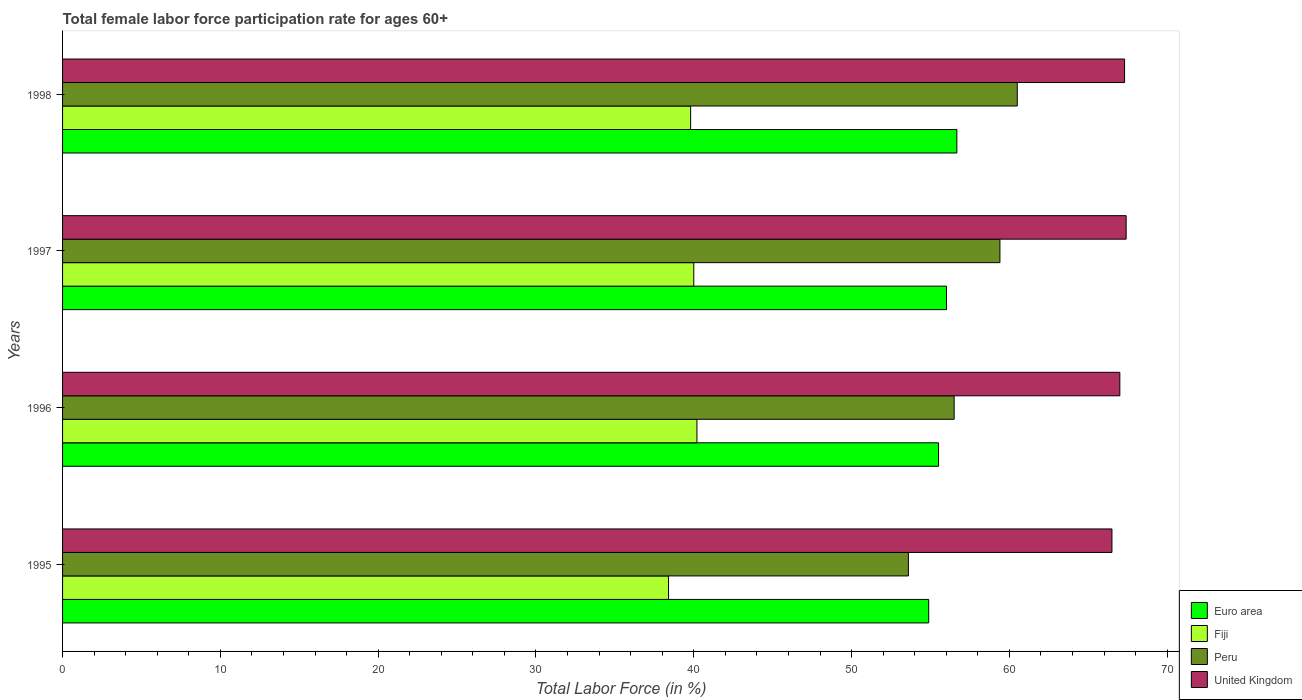How many different coloured bars are there?
Ensure brevity in your answer.  4. How many groups of bars are there?
Your answer should be compact. 4. How many bars are there on the 4th tick from the top?
Provide a short and direct response. 4. How many bars are there on the 3rd tick from the bottom?
Provide a short and direct response. 4. What is the label of the 1st group of bars from the top?
Give a very brief answer. 1998. In how many cases, is the number of bars for a given year not equal to the number of legend labels?
Ensure brevity in your answer.  0. What is the female labor force participation rate in Peru in 1996?
Give a very brief answer. 56.5. Across all years, what is the maximum female labor force participation rate in United Kingdom?
Give a very brief answer. 67.4. Across all years, what is the minimum female labor force participation rate in United Kingdom?
Give a very brief answer. 66.5. What is the total female labor force participation rate in Peru in the graph?
Give a very brief answer. 230. What is the difference between the female labor force participation rate in Fiji in 1997 and that in 1998?
Your answer should be compact. 0.2. What is the difference between the female labor force participation rate in Peru in 1996 and the female labor force participation rate in United Kingdom in 1995?
Make the answer very short. -10. What is the average female labor force participation rate in Fiji per year?
Provide a succinct answer. 39.6. In the year 1995, what is the difference between the female labor force participation rate in Fiji and female labor force participation rate in Peru?
Offer a terse response. -15.2. In how many years, is the female labor force participation rate in Peru greater than 6 %?
Ensure brevity in your answer.  4. What is the ratio of the female labor force participation rate in Euro area in 1997 to that in 1998?
Your answer should be very brief. 0.99. Is the difference between the female labor force participation rate in Fiji in 1996 and 1998 greater than the difference between the female labor force participation rate in Peru in 1996 and 1998?
Ensure brevity in your answer.  Yes. What is the difference between the highest and the second highest female labor force participation rate in Fiji?
Keep it short and to the point. 0.2. What is the difference between the highest and the lowest female labor force participation rate in United Kingdom?
Provide a short and direct response. 0.9. Is the sum of the female labor force participation rate in Fiji in 1996 and 1997 greater than the maximum female labor force participation rate in United Kingdom across all years?
Provide a succinct answer. Yes. Is it the case that in every year, the sum of the female labor force participation rate in Fiji and female labor force participation rate in Euro area is greater than the sum of female labor force participation rate in United Kingdom and female labor force participation rate in Peru?
Your answer should be very brief. No. Is it the case that in every year, the sum of the female labor force participation rate in Peru and female labor force participation rate in Euro area is greater than the female labor force participation rate in United Kingdom?
Your response must be concise. Yes. How many bars are there?
Your response must be concise. 16. Are all the bars in the graph horizontal?
Make the answer very short. Yes. What is the difference between two consecutive major ticks on the X-axis?
Ensure brevity in your answer.  10. Are the values on the major ticks of X-axis written in scientific E-notation?
Your answer should be compact. No. Does the graph contain any zero values?
Your response must be concise. No. Does the graph contain grids?
Ensure brevity in your answer.  No. How are the legend labels stacked?
Provide a succinct answer. Vertical. What is the title of the graph?
Offer a very short reply. Total female labor force participation rate for ages 60+. Does "Qatar" appear as one of the legend labels in the graph?
Your answer should be compact. No. What is the label or title of the X-axis?
Your answer should be very brief. Total Labor Force (in %). What is the label or title of the Y-axis?
Your answer should be compact. Years. What is the Total Labor Force (in %) of Euro area in 1995?
Offer a very short reply. 54.89. What is the Total Labor Force (in %) in Fiji in 1995?
Your response must be concise. 38.4. What is the Total Labor Force (in %) in Peru in 1995?
Provide a short and direct response. 53.6. What is the Total Labor Force (in %) in United Kingdom in 1995?
Offer a very short reply. 66.5. What is the Total Labor Force (in %) of Euro area in 1996?
Your response must be concise. 55.51. What is the Total Labor Force (in %) of Fiji in 1996?
Your answer should be compact. 40.2. What is the Total Labor Force (in %) of Peru in 1996?
Provide a short and direct response. 56.5. What is the Total Labor Force (in %) of Euro area in 1997?
Your answer should be compact. 56.02. What is the Total Labor Force (in %) of Fiji in 1997?
Provide a short and direct response. 40. What is the Total Labor Force (in %) in Peru in 1997?
Offer a terse response. 59.4. What is the Total Labor Force (in %) in United Kingdom in 1997?
Your response must be concise. 67.4. What is the Total Labor Force (in %) in Euro area in 1998?
Your answer should be very brief. 56.67. What is the Total Labor Force (in %) in Fiji in 1998?
Provide a short and direct response. 39.8. What is the Total Labor Force (in %) of Peru in 1998?
Keep it short and to the point. 60.5. What is the Total Labor Force (in %) in United Kingdom in 1998?
Offer a very short reply. 67.3. Across all years, what is the maximum Total Labor Force (in %) of Euro area?
Your answer should be compact. 56.67. Across all years, what is the maximum Total Labor Force (in %) of Fiji?
Ensure brevity in your answer.  40.2. Across all years, what is the maximum Total Labor Force (in %) of Peru?
Offer a terse response. 60.5. Across all years, what is the maximum Total Labor Force (in %) in United Kingdom?
Offer a terse response. 67.4. Across all years, what is the minimum Total Labor Force (in %) of Euro area?
Offer a terse response. 54.89. Across all years, what is the minimum Total Labor Force (in %) in Fiji?
Your answer should be compact. 38.4. Across all years, what is the minimum Total Labor Force (in %) in Peru?
Offer a very short reply. 53.6. Across all years, what is the minimum Total Labor Force (in %) of United Kingdom?
Offer a very short reply. 66.5. What is the total Total Labor Force (in %) of Euro area in the graph?
Provide a short and direct response. 223.08. What is the total Total Labor Force (in %) of Fiji in the graph?
Keep it short and to the point. 158.4. What is the total Total Labor Force (in %) in Peru in the graph?
Give a very brief answer. 230. What is the total Total Labor Force (in %) of United Kingdom in the graph?
Ensure brevity in your answer.  268.2. What is the difference between the Total Labor Force (in %) of Euro area in 1995 and that in 1996?
Keep it short and to the point. -0.62. What is the difference between the Total Labor Force (in %) of United Kingdom in 1995 and that in 1996?
Offer a very short reply. -0.5. What is the difference between the Total Labor Force (in %) of Euro area in 1995 and that in 1997?
Give a very brief answer. -1.13. What is the difference between the Total Labor Force (in %) in United Kingdom in 1995 and that in 1997?
Your answer should be compact. -0.9. What is the difference between the Total Labor Force (in %) of Euro area in 1995 and that in 1998?
Make the answer very short. -1.78. What is the difference between the Total Labor Force (in %) of United Kingdom in 1995 and that in 1998?
Make the answer very short. -0.8. What is the difference between the Total Labor Force (in %) in Euro area in 1996 and that in 1997?
Keep it short and to the point. -0.51. What is the difference between the Total Labor Force (in %) of Fiji in 1996 and that in 1997?
Provide a short and direct response. 0.2. What is the difference between the Total Labor Force (in %) in Peru in 1996 and that in 1997?
Offer a very short reply. -2.9. What is the difference between the Total Labor Force (in %) of United Kingdom in 1996 and that in 1997?
Offer a terse response. -0.4. What is the difference between the Total Labor Force (in %) in Euro area in 1996 and that in 1998?
Make the answer very short. -1.16. What is the difference between the Total Labor Force (in %) in Peru in 1996 and that in 1998?
Offer a terse response. -4. What is the difference between the Total Labor Force (in %) in United Kingdom in 1996 and that in 1998?
Make the answer very short. -0.3. What is the difference between the Total Labor Force (in %) of Euro area in 1997 and that in 1998?
Make the answer very short. -0.65. What is the difference between the Total Labor Force (in %) of United Kingdom in 1997 and that in 1998?
Provide a succinct answer. 0.1. What is the difference between the Total Labor Force (in %) of Euro area in 1995 and the Total Labor Force (in %) of Fiji in 1996?
Your answer should be very brief. 14.69. What is the difference between the Total Labor Force (in %) of Euro area in 1995 and the Total Labor Force (in %) of Peru in 1996?
Ensure brevity in your answer.  -1.61. What is the difference between the Total Labor Force (in %) of Euro area in 1995 and the Total Labor Force (in %) of United Kingdom in 1996?
Your answer should be very brief. -12.11. What is the difference between the Total Labor Force (in %) of Fiji in 1995 and the Total Labor Force (in %) of Peru in 1996?
Offer a terse response. -18.1. What is the difference between the Total Labor Force (in %) in Fiji in 1995 and the Total Labor Force (in %) in United Kingdom in 1996?
Your answer should be very brief. -28.6. What is the difference between the Total Labor Force (in %) in Peru in 1995 and the Total Labor Force (in %) in United Kingdom in 1996?
Ensure brevity in your answer.  -13.4. What is the difference between the Total Labor Force (in %) in Euro area in 1995 and the Total Labor Force (in %) in Fiji in 1997?
Offer a very short reply. 14.89. What is the difference between the Total Labor Force (in %) in Euro area in 1995 and the Total Labor Force (in %) in Peru in 1997?
Offer a terse response. -4.51. What is the difference between the Total Labor Force (in %) in Euro area in 1995 and the Total Labor Force (in %) in United Kingdom in 1997?
Give a very brief answer. -12.51. What is the difference between the Total Labor Force (in %) in Fiji in 1995 and the Total Labor Force (in %) in Peru in 1997?
Your answer should be compact. -21. What is the difference between the Total Labor Force (in %) of Fiji in 1995 and the Total Labor Force (in %) of United Kingdom in 1997?
Offer a very short reply. -29. What is the difference between the Total Labor Force (in %) of Euro area in 1995 and the Total Labor Force (in %) of Fiji in 1998?
Your answer should be very brief. 15.09. What is the difference between the Total Labor Force (in %) in Euro area in 1995 and the Total Labor Force (in %) in Peru in 1998?
Provide a succinct answer. -5.61. What is the difference between the Total Labor Force (in %) of Euro area in 1995 and the Total Labor Force (in %) of United Kingdom in 1998?
Make the answer very short. -12.41. What is the difference between the Total Labor Force (in %) of Fiji in 1995 and the Total Labor Force (in %) of Peru in 1998?
Make the answer very short. -22.1. What is the difference between the Total Labor Force (in %) in Fiji in 1995 and the Total Labor Force (in %) in United Kingdom in 1998?
Make the answer very short. -28.9. What is the difference between the Total Labor Force (in %) in Peru in 1995 and the Total Labor Force (in %) in United Kingdom in 1998?
Your answer should be very brief. -13.7. What is the difference between the Total Labor Force (in %) of Euro area in 1996 and the Total Labor Force (in %) of Fiji in 1997?
Your response must be concise. 15.51. What is the difference between the Total Labor Force (in %) in Euro area in 1996 and the Total Labor Force (in %) in Peru in 1997?
Your response must be concise. -3.89. What is the difference between the Total Labor Force (in %) of Euro area in 1996 and the Total Labor Force (in %) of United Kingdom in 1997?
Your answer should be very brief. -11.89. What is the difference between the Total Labor Force (in %) in Fiji in 1996 and the Total Labor Force (in %) in Peru in 1997?
Offer a terse response. -19.2. What is the difference between the Total Labor Force (in %) in Fiji in 1996 and the Total Labor Force (in %) in United Kingdom in 1997?
Give a very brief answer. -27.2. What is the difference between the Total Labor Force (in %) of Peru in 1996 and the Total Labor Force (in %) of United Kingdom in 1997?
Ensure brevity in your answer.  -10.9. What is the difference between the Total Labor Force (in %) of Euro area in 1996 and the Total Labor Force (in %) of Fiji in 1998?
Make the answer very short. 15.71. What is the difference between the Total Labor Force (in %) in Euro area in 1996 and the Total Labor Force (in %) in Peru in 1998?
Your answer should be very brief. -4.99. What is the difference between the Total Labor Force (in %) of Euro area in 1996 and the Total Labor Force (in %) of United Kingdom in 1998?
Provide a succinct answer. -11.79. What is the difference between the Total Labor Force (in %) of Fiji in 1996 and the Total Labor Force (in %) of Peru in 1998?
Your response must be concise. -20.3. What is the difference between the Total Labor Force (in %) of Fiji in 1996 and the Total Labor Force (in %) of United Kingdom in 1998?
Your answer should be very brief. -27.1. What is the difference between the Total Labor Force (in %) in Peru in 1996 and the Total Labor Force (in %) in United Kingdom in 1998?
Ensure brevity in your answer.  -10.8. What is the difference between the Total Labor Force (in %) of Euro area in 1997 and the Total Labor Force (in %) of Fiji in 1998?
Make the answer very short. 16.22. What is the difference between the Total Labor Force (in %) in Euro area in 1997 and the Total Labor Force (in %) in Peru in 1998?
Your answer should be compact. -4.48. What is the difference between the Total Labor Force (in %) in Euro area in 1997 and the Total Labor Force (in %) in United Kingdom in 1998?
Give a very brief answer. -11.28. What is the difference between the Total Labor Force (in %) in Fiji in 1997 and the Total Labor Force (in %) in Peru in 1998?
Keep it short and to the point. -20.5. What is the difference between the Total Labor Force (in %) of Fiji in 1997 and the Total Labor Force (in %) of United Kingdom in 1998?
Your answer should be compact. -27.3. What is the difference between the Total Labor Force (in %) of Peru in 1997 and the Total Labor Force (in %) of United Kingdom in 1998?
Provide a short and direct response. -7.9. What is the average Total Labor Force (in %) in Euro area per year?
Make the answer very short. 55.77. What is the average Total Labor Force (in %) of Fiji per year?
Your answer should be very brief. 39.6. What is the average Total Labor Force (in %) of Peru per year?
Keep it short and to the point. 57.5. What is the average Total Labor Force (in %) in United Kingdom per year?
Ensure brevity in your answer.  67.05. In the year 1995, what is the difference between the Total Labor Force (in %) of Euro area and Total Labor Force (in %) of Fiji?
Provide a short and direct response. 16.49. In the year 1995, what is the difference between the Total Labor Force (in %) in Euro area and Total Labor Force (in %) in Peru?
Your answer should be very brief. 1.29. In the year 1995, what is the difference between the Total Labor Force (in %) in Euro area and Total Labor Force (in %) in United Kingdom?
Offer a very short reply. -11.61. In the year 1995, what is the difference between the Total Labor Force (in %) in Fiji and Total Labor Force (in %) in Peru?
Ensure brevity in your answer.  -15.2. In the year 1995, what is the difference between the Total Labor Force (in %) in Fiji and Total Labor Force (in %) in United Kingdom?
Offer a very short reply. -28.1. In the year 1995, what is the difference between the Total Labor Force (in %) of Peru and Total Labor Force (in %) of United Kingdom?
Make the answer very short. -12.9. In the year 1996, what is the difference between the Total Labor Force (in %) in Euro area and Total Labor Force (in %) in Fiji?
Ensure brevity in your answer.  15.31. In the year 1996, what is the difference between the Total Labor Force (in %) in Euro area and Total Labor Force (in %) in Peru?
Offer a very short reply. -0.99. In the year 1996, what is the difference between the Total Labor Force (in %) in Euro area and Total Labor Force (in %) in United Kingdom?
Offer a terse response. -11.49. In the year 1996, what is the difference between the Total Labor Force (in %) in Fiji and Total Labor Force (in %) in Peru?
Your answer should be compact. -16.3. In the year 1996, what is the difference between the Total Labor Force (in %) in Fiji and Total Labor Force (in %) in United Kingdom?
Provide a short and direct response. -26.8. In the year 1996, what is the difference between the Total Labor Force (in %) in Peru and Total Labor Force (in %) in United Kingdom?
Your response must be concise. -10.5. In the year 1997, what is the difference between the Total Labor Force (in %) in Euro area and Total Labor Force (in %) in Fiji?
Provide a short and direct response. 16.02. In the year 1997, what is the difference between the Total Labor Force (in %) in Euro area and Total Labor Force (in %) in Peru?
Your answer should be compact. -3.38. In the year 1997, what is the difference between the Total Labor Force (in %) in Euro area and Total Labor Force (in %) in United Kingdom?
Provide a short and direct response. -11.38. In the year 1997, what is the difference between the Total Labor Force (in %) of Fiji and Total Labor Force (in %) of Peru?
Offer a terse response. -19.4. In the year 1997, what is the difference between the Total Labor Force (in %) in Fiji and Total Labor Force (in %) in United Kingdom?
Give a very brief answer. -27.4. In the year 1997, what is the difference between the Total Labor Force (in %) in Peru and Total Labor Force (in %) in United Kingdom?
Offer a terse response. -8. In the year 1998, what is the difference between the Total Labor Force (in %) in Euro area and Total Labor Force (in %) in Fiji?
Your response must be concise. 16.87. In the year 1998, what is the difference between the Total Labor Force (in %) of Euro area and Total Labor Force (in %) of Peru?
Keep it short and to the point. -3.83. In the year 1998, what is the difference between the Total Labor Force (in %) of Euro area and Total Labor Force (in %) of United Kingdom?
Provide a succinct answer. -10.63. In the year 1998, what is the difference between the Total Labor Force (in %) in Fiji and Total Labor Force (in %) in Peru?
Keep it short and to the point. -20.7. In the year 1998, what is the difference between the Total Labor Force (in %) in Fiji and Total Labor Force (in %) in United Kingdom?
Your response must be concise. -27.5. What is the ratio of the Total Labor Force (in %) of Euro area in 1995 to that in 1996?
Your response must be concise. 0.99. What is the ratio of the Total Labor Force (in %) of Fiji in 1995 to that in 1996?
Give a very brief answer. 0.96. What is the ratio of the Total Labor Force (in %) in Peru in 1995 to that in 1996?
Your response must be concise. 0.95. What is the ratio of the Total Labor Force (in %) of United Kingdom in 1995 to that in 1996?
Make the answer very short. 0.99. What is the ratio of the Total Labor Force (in %) in Euro area in 1995 to that in 1997?
Give a very brief answer. 0.98. What is the ratio of the Total Labor Force (in %) of Fiji in 1995 to that in 1997?
Your response must be concise. 0.96. What is the ratio of the Total Labor Force (in %) in Peru in 1995 to that in 1997?
Ensure brevity in your answer.  0.9. What is the ratio of the Total Labor Force (in %) in United Kingdom in 1995 to that in 1997?
Offer a very short reply. 0.99. What is the ratio of the Total Labor Force (in %) of Euro area in 1995 to that in 1998?
Provide a short and direct response. 0.97. What is the ratio of the Total Labor Force (in %) of Fiji in 1995 to that in 1998?
Provide a short and direct response. 0.96. What is the ratio of the Total Labor Force (in %) of Peru in 1995 to that in 1998?
Provide a short and direct response. 0.89. What is the ratio of the Total Labor Force (in %) in United Kingdom in 1995 to that in 1998?
Your answer should be compact. 0.99. What is the ratio of the Total Labor Force (in %) of Peru in 1996 to that in 1997?
Give a very brief answer. 0.95. What is the ratio of the Total Labor Force (in %) in United Kingdom in 1996 to that in 1997?
Your response must be concise. 0.99. What is the ratio of the Total Labor Force (in %) in Euro area in 1996 to that in 1998?
Keep it short and to the point. 0.98. What is the ratio of the Total Labor Force (in %) of Fiji in 1996 to that in 1998?
Offer a very short reply. 1.01. What is the ratio of the Total Labor Force (in %) in Peru in 1996 to that in 1998?
Make the answer very short. 0.93. What is the ratio of the Total Labor Force (in %) in United Kingdom in 1996 to that in 1998?
Keep it short and to the point. 1. What is the ratio of the Total Labor Force (in %) of Euro area in 1997 to that in 1998?
Give a very brief answer. 0.99. What is the ratio of the Total Labor Force (in %) of Fiji in 1997 to that in 1998?
Your answer should be very brief. 1. What is the ratio of the Total Labor Force (in %) of Peru in 1997 to that in 1998?
Make the answer very short. 0.98. What is the difference between the highest and the second highest Total Labor Force (in %) in Euro area?
Your response must be concise. 0.65. What is the difference between the highest and the lowest Total Labor Force (in %) in Euro area?
Ensure brevity in your answer.  1.78. What is the difference between the highest and the lowest Total Labor Force (in %) in Peru?
Offer a very short reply. 6.9. What is the difference between the highest and the lowest Total Labor Force (in %) in United Kingdom?
Give a very brief answer. 0.9. 